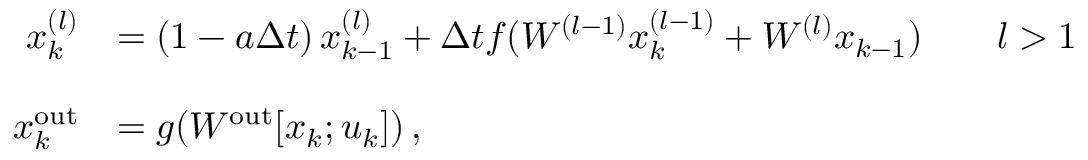Convert formula to latex. <formula><loc_0><loc_0><loc_500><loc_500>\begin{array} { r l } { x _ { k } ^ { ( l ) } } & { = \left ( 1 - a \Delta t \right ) x _ { k - 1 } ^ { ( l ) } + \Delta t f ( W ^ { ( l - 1 ) } x _ { k } ^ { ( l - 1 ) } + W ^ { ( l ) } x _ { k - 1 } ) \quad l > 1 } \\ \\ { x _ { k } ^ { o u t } } & { = g ( W ^ { o u t } [ x _ { k } ; u _ { k } ] ) \, , } \end{array}</formula> 